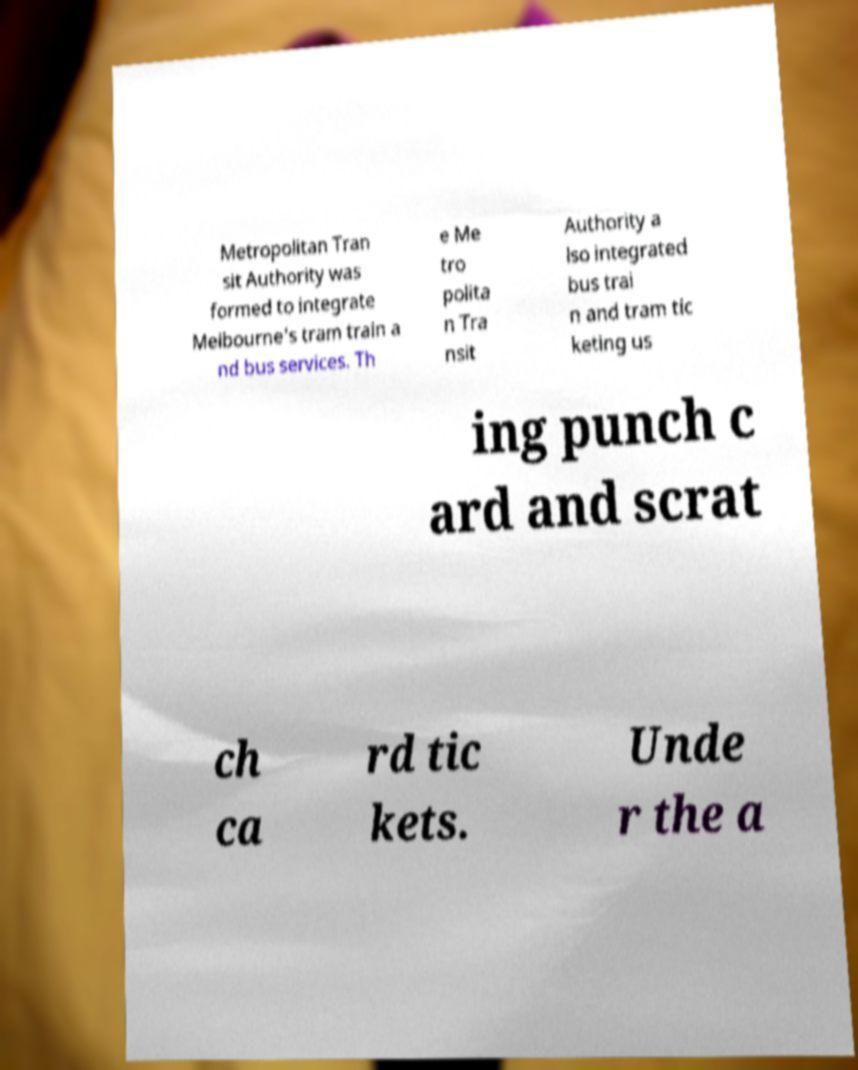Please identify and transcribe the text found in this image. Metropolitan Tran sit Authority was formed to integrate Melbourne's tram train a nd bus services. Th e Me tro polita n Tra nsit Authority a lso integrated bus trai n and tram tic keting us ing punch c ard and scrat ch ca rd tic kets. Unde r the a 